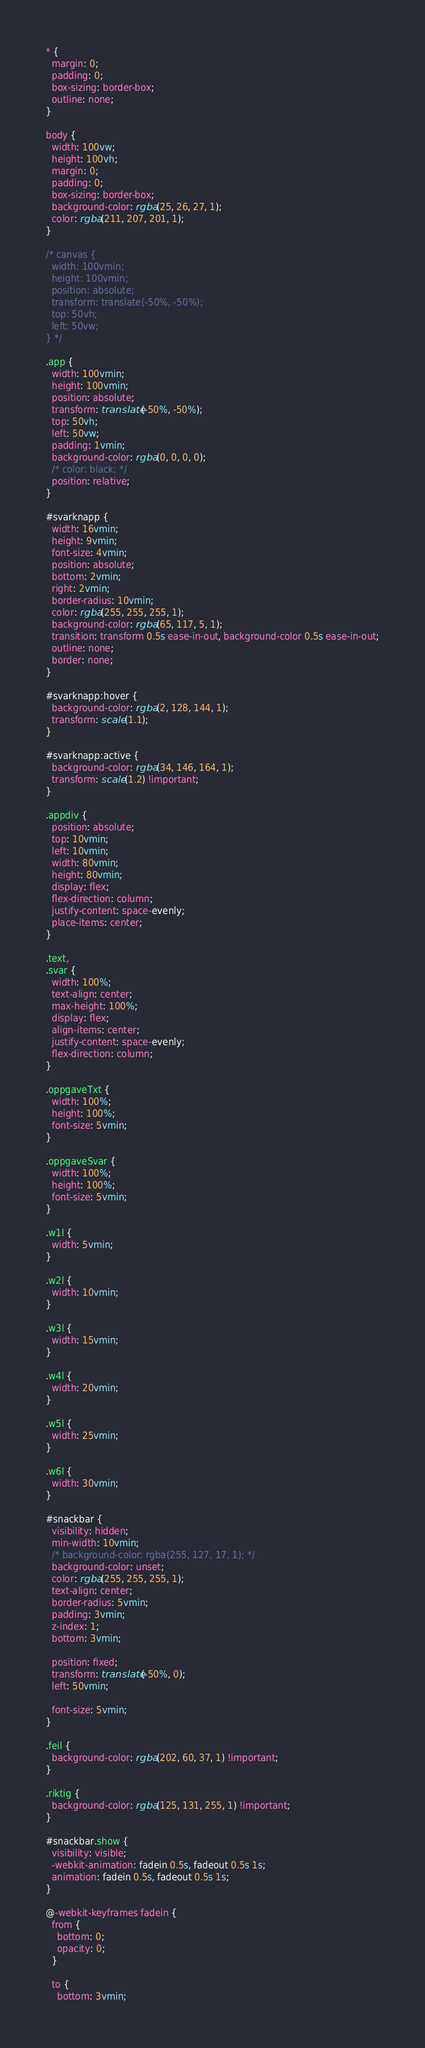<code> <loc_0><loc_0><loc_500><loc_500><_CSS_>* {
  margin: 0;
  padding: 0;
  box-sizing: border-box;
  outline: none;
}

body {
  width: 100vw;
  height: 100vh;
  margin: 0;
  padding: 0;
  box-sizing: border-box;
  background-color: rgba(25, 26, 27, 1);
  color: rgba(211, 207, 201, 1);
}

/* canvas {
  width: 100vmin;
  height: 100vmin;
  position: absolute;
  transform: translate(-50%, -50%);
  top: 50vh;
  left: 50vw;
} */

.app {
  width: 100vmin;
  height: 100vmin;
  position: absolute;
  transform: translate(-50%, -50%);
  top: 50vh;
  left: 50vw;
  padding: 1vmin;
  background-color: rgba(0, 0, 0, 0);
  /* color: black; */
  position: relative;
}

#svarknapp {
  width: 16vmin;
  height: 9vmin;
  font-size: 4vmin;
  position: absolute;
  bottom: 2vmin;
  right: 2vmin;
  border-radius: 10vmin;
  color: rgba(255, 255, 255, 1);
  background-color: rgba(65, 117, 5, 1);
  transition: transform 0.5s ease-in-out, background-color 0.5s ease-in-out;
  outline: none;
  border: none;
}

#svarknapp:hover {
  background-color: rgba(2, 128, 144, 1);
  transform: scale(1.1);
}

#svarknapp:active {
  background-color: rgba(34, 146, 164, 1);
  transform: scale(1.2) !important;
}

.appdiv {
  position: absolute;
  top: 10vmin;
  left: 10vmin;
  width: 80vmin;
  height: 80vmin;
  display: flex;
  flex-direction: column;
  justify-content: space-evenly;
  place-items: center;
}

.text,
.svar {
  width: 100%;
  text-align: center;
  max-height: 100%;
  display: flex;
  align-items: center;
  justify-content: space-evenly;
  flex-direction: column;
}

.oppgaveTxt {
  width: 100%;
  height: 100%;
  font-size: 5vmin;
}

.oppgaveSvar {
  width: 100%;
  height: 100%;
  font-size: 5vmin;
}

.w1l {
  width: 5vmin;
}

.w2l {
  width: 10vmin;
}

.w3l {
  width: 15vmin;
}

.w4l {
  width: 20vmin;
}

.w5l {
  width: 25vmin;
}

.w6l {
  width: 30vmin;
}

#snackbar {
  visibility: hidden;
  min-width: 10vmin;
  /* background-color: rgba(255, 127, 17, 1); */
  background-color: unset;
  color: rgba(255, 255, 255, 1);
  text-align: center;
  border-radius: 5vmin;
  padding: 3vmin;
  z-index: 1;
  bottom: 3vmin;

  position: fixed;
  transform: translate(-50%, 0);
  left: 50vmin;

  font-size: 5vmin;
}

.feil {
  background-color: rgba(202, 60, 37, 1) !important;
}

.riktig {
  background-color: rgba(125, 131, 255, 1) !important;
}

#snackbar.show {
  visibility: visible;
  -webkit-animation: fadein 0.5s, fadeout 0.5s 1s;
  animation: fadein 0.5s, fadeout 0.5s 1s;
}

@-webkit-keyframes fadein {
  from {
    bottom: 0;
    opacity: 0;
  }

  to {
    bottom: 3vmin;</code> 